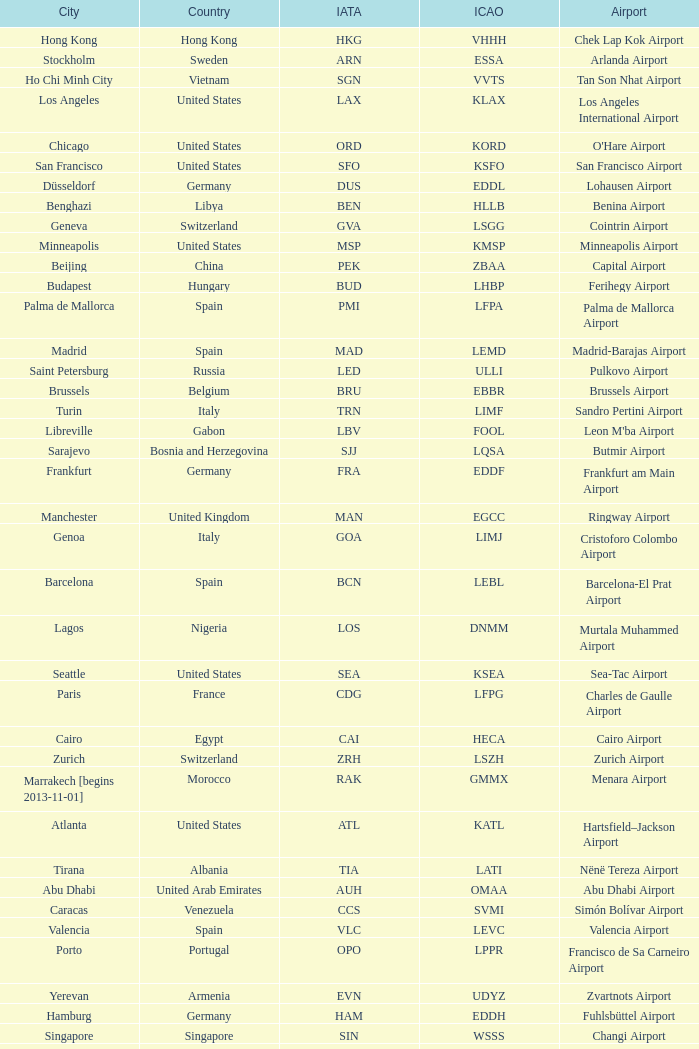Could you parse the entire table? {'header': ['City', 'Country', 'IATA', 'ICAO', 'Airport'], 'rows': [['Hong Kong', 'Hong Kong', 'HKG', 'VHHH', 'Chek Lap Kok Airport'], ['Stockholm', 'Sweden', 'ARN', 'ESSA', 'Arlanda Airport'], ['Ho Chi Minh City', 'Vietnam', 'SGN', 'VVTS', 'Tan Son Nhat Airport'], ['Los Angeles', 'United States', 'LAX', 'KLAX', 'Los Angeles International Airport'], ['Chicago', 'United States', 'ORD', 'KORD', "O'Hare Airport"], ['San Francisco', 'United States', 'SFO', 'KSFO', 'San Francisco Airport'], ['Düsseldorf', 'Germany', 'DUS', 'EDDL', 'Lohausen Airport'], ['Benghazi', 'Libya', 'BEN', 'HLLB', 'Benina Airport'], ['Geneva', 'Switzerland', 'GVA', 'LSGG', 'Cointrin Airport'], ['Minneapolis', 'United States', 'MSP', 'KMSP', 'Minneapolis Airport'], ['Beijing', 'China', 'PEK', 'ZBAA', 'Capital Airport'], ['Budapest', 'Hungary', 'BUD', 'LHBP', 'Ferihegy Airport'], ['Palma de Mallorca', 'Spain', 'PMI', 'LFPA', 'Palma de Mallorca Airport'], ['Madrid', 'Spain', 'MAD', 'LEMD', 'Madrid-Barajas Airport'], ['Saint Petersburg', 'Russia', 'LED', 'ULLI', 'Pulkovo Airport'], ['Brussels', 'Belgium', 'BRU', 'EBBR', 'Brussels Airport'], ['Turin', 'Italy', 'TRN', 'LIMF', 'Sandro Pertini Airport'], ['Libreville', 'Gabon', 'LBV', 'FOOL', "Leon M'ba Airport"], ['Sarajevo', 'Bosnia and Herzegovina', 'SJJ', 'LQSA', 'Butmir Airport'], ['Frankfurt', 'Germany', 'FRA', 'EDDF', 'Frankfurt am Main Airport'], ['Manchester', 'United Kingdom', 'MAN', 'EGCC', 'Ringway Airport'], ['Genoa', 'Italy', 'GOA', 'LIMJ', 'Cristoforo Colombo Airport'], ['Barcelona', 'Spain', 'BCN', 'LEBL', 'Barcelona-El Prat Airport'], ['Lagos', 'Nigeria', 'LOS', 'DNMM', 'Murtala Muhammed Airport'], ['Seattle', 'United States', 'SEA', 'KSEA', 'Sea-Tac Airport'], ['Paris', 'France', 'CDG', 'LFPG', 'Charles de Gaulle Airport'], ['Cairo', 'Egypt', 'CAI', 'HECA', 'Cairo Airport'], ['Zurich', 'Switzerland', 'ZRH', 'LSZH', 'Zurich Airport'], ['Marrakech [begins 2013-11-01]', 'Morocco', 'RAK', 'GMMX', 'Menara Airport'], ['Atlanta', 'United States', 'ATL', 'KATL', 'Hartsfield–Jackson Airport'], ['Tirana', 'Albania', 'TIA', 'LATI', 'Nënë Tereza Airport'], ['Abu Dhabi', 'United Arab Emirates', 'AUH', 'OMAA', 'Abu Dhabi Airport'], ['Caracas', 'Venezuela', 'CCS', 'SVMI', 'Simón Bolívar Airport'], ['Valencia', 'Spain', 'VLC', 'LEVC', 'Valencia Airport'], ['Porto', 'Portugal', 'OPO', 'LPPR', 'Francisco de Sa Carneiro Airport'], ['Yerevan', 'Armenia', 'EVN', 'UDYZ', 'Zvartnots Airport'], ['Hamburg', 'Germany', 'HAM', 'EDDH', 'Fuhlsbüttel Airport'], ['Singapore', 'Singapore', 'SIN', 'WSSS', 'Changi Airport'], ['Munich', 'Germany', 'MUC', 'EDDM', 'Franz Josef Strauss Airport'], ['Thessaloniki', 'Greece', 'SKG', 'LGTS', 'Macedonia Airport'], ['Gothenburg [begins 2013-12-14]', 'Sweden', 'GOT', 'ESGG', 'Gothenburg-Landvetter Airport'], ['Basel Mulhouse Freiburg', 'Switzerland France Germany', 'BSL MLH EAP', 'LFSB', 'Euro Airport'], ['Copenhagen', 'Denmark', 'CPH', 'EKCH', 'Kastrup Airport'], ['London', 'United Kingdom', 'LHR', 'EGLL', 'Heathrow Airport'], ['Tunis', 'Tunisia', 'TUN', 'DTTA', 'Carthage Airport'], ['Accra', 'Ghana', 'ACC', 'DGAA', 'Kotoka Airport'], ['Prague', 'Czech Republic', 'PRG', 'LKPR', 'Ruzyně Airport'], ['New York City', 'United States', 'JFK', 'KJFK', 'John F Kennedy Airport'], ['Malaga', 'Spain', 'AGP', 'LEMG', 'Málaga-Costa del Sol Airport'], ['Stuttgart', 'Germany', 'STR', 'EDDS', 'Echterdingen Airport'], ['Istanbul', 'Turkey', 'IST', 'LTBA', 'Atatürk Airport'], ['Helsinki', 'Finland', 'HEL', 'EFHK', 'Vantaa Airport'], ['Tel Aviv', 'Israel', 'TLV', 'LLBG', 'Ben Gurion Airport'], ['Tehran', 'Iran', 'IKA', 'OIIE', 'Imam Khomeini Airport'], ['Lugano', 'Switzerland', 'LUG', 'LSZA', 'Agno Airport'], ['Bucharest', 'Romania', 'OTP', 'LROP', 'Otopeni Airport'], ['Lyon', 'France', 'LYS', 'LFLL', 'Saint-Exupéry Airport'], ['Karachi', 'Pakistan', 'KHI', 'OPKC', 'Jinnah Airport'], ['Florence', 'Italy', 'FLR', 'LIRQ', 'Peretola Airport'], ['Oslo', 'Norway', 'OSL', 'ENGM', 'Gardermoen Airport'], ['Riga', 'Latvia', 'RIX', 'EVRA', 'Riga Airport'], ['Luxembourg City', 'Luxembourg', 'LUX', 'ELLX', 'Findel Airport'], ['Amsterdam', 'Netherlands', 'AMS', 'EHAM', 'Amsterdam Airport Schiphol'], ['Moscow', 'Russia', 'DME', 'UUDD', 'Domodedovo Airport'], ['Venice', 'Italy', 'VCE', 'LIPZ', 'Marco Polo Airport'], ['Hannover', 'Germany', 'HAJ', 'EDDV', 'Langenhagen Airport'], ['Miami', 'United States', 'MIA', 'KMIA', 'Miami Airport'], ['Jeddah', 'Saudi Arabia', 'JED', 'OEJN', 'King Abdulaziz Airport'], ['London', 'United Kingdom', 'LCY', 'EGLC', 'City Airport'], ['Nuremberg', 'Germany', 'NUE', 'EDDN', 'Nuremberg Airport'], ['Dar es Salaam', 'Tanzania', 'DAR', 'HTDA', 'Julius Nyerere Airport'], ['Vienna', 'Austria', 'VIE', 'LOWW', 'Schwechat Airport'], ['Belgrade', 'Serbia', 'BEG', 'LYBE', 'Nikola Tesla Airport'], ['Mumbai', 'India', 'BOM', 'VABB', 'Chhatrapati Shivaji Airport'], ['Muscat', 'Oman', 'MCT', 'OOMS', 'Seeb Airport'], ['Tripoli', 'Libya', 'TIP', 'HLLT', 'Tripoli Airport'], ['Dublin', 'Ireland', 'DUB', 'EIDW', 'Dublin Airport'], ['Nice', 'France', 'NCE', 'LFMN', "Côte d'Azur Airport"], ['Tokyo', 'Japan', 'NRT', 'RJAA', 'Narita Airport'], ['Dubai', 'United Arab Emirates', 'DXB', 'OMDB', 'Dubai Airport'], ['Sofia', 'Bulgaria', 'SOF', 'LBSF', 'Vrazhdebna Airport'], ['São Paulo', 'Brazil', 'GRU', 'SBGR', 'Guarulhos Airport'], ['Bilbao', 'Spain', 'BIO', 'LEBB', 'Bilbao Airport'], ['Buenos Aires', 'Argentina', 'EZE', 'SAEZ', 'Ministro Pistarini Airport (Ezeiza)'], ['Manila', 'Philippines', 'MNL', 'RPLL', 'Ninoy Aquino Airport'], ['Birmingham', 'United Kingdom', 'BHX', 'EGBB', 'Birmingham Airport'], ['Milan', 'Italy', 'MXP', 'LIMC', 'Malpensa Airport'], ['Douala', 'Cameroon', 'DLA', 'FKKD', 'Douala Airport'], ['London [begins 2013-12-14]', 'United Kingdom', 'LGW', 'EGKK', 'Gatwick Airport'], ['Newark', 'United States', 'EWR', 'KEWR', 'Liberty Airport'], ['Santiago', 'Chile', 'SCL', 'SCEL', 'Comodoro Arturo Benitez Airport'], ['Riyadh', 'Saudi Arabia', 'RUH', 'OERK', 'King Khalid Airport'], ['Beirut', 'Lebanon', 'BEY', 'OLBA', 'Rafic Hariri Airport'], ['Bangkok', 'Thailand', 'BKK', 'VTBS', 'Suvarnabhumi Airport'], ['Rio de Janeiro [resumes 2014-7-14]', 'Brazil', 'GIG', 'SBGL', 'Galeão Airport'], ['Warsaw', 'Poland', 'WAW', 'EPWA', 'Frederic Chopin Airport'], ['Yaounde', 'Cameroon', 'NSI', 'FKYS', 'Yaounde Nsimalen Airport'], ['Malabo', 'Equatorial Guinea', 'SSG', 'FGSL', 'Saint Isabel Airport'], ['Johannesburg', 'South Africa', 'JNB', 'FAJS', 'OR Tambo Airport'], ['Washington DC', 'United States', 'IAD', 'KIAD', 'Dulles Airport'], ['Kiev', 'Ukraine', 'KBP', 'UKBB', 'Boryspil International Airport'], ['Jakarta', 'Indonesia', 'CGK', 'WIII', 'Soekarno–Hatta Airport'], ['Skopje', 'Republic of Macedonia', 'SKP', 'LWSK', 'Alexander the Great Airport'], ['Berlin', 'Germany', 'TXL', 'EDDT', 'Tegel Airport'], ['Casablanca', 'Morocco', 'CMN', 'GMMN', 'Mohammed V Airport'], ['Montreal', 'Canada', 'YUL', 'CYUL', 'Pierre Elliott Trudeau Airport'], ['Taipei', 'Taiwan', 'TPE', 'RCTP', 'Taoyuan Airport'], ['Toronto', 'Canada', 'YYZ', 'CYYZ', 'Pearson Airport'], ['Delhi', 'India', 'DEL', 'VIDP', 'Indira Gandhi Airport'], ['Nairobi', 'Kenya', 'NBO', 'HKJK', 'Jomo Kenyatta Airport'], ['Rome', 'Italy', 'FCO', 'LIRF', 'Leonardo da Vinci Airport'], ['Athens', 'Greece', 'ATH', 'LGAV', 'Eleftherios Venizelos Airport'], ['Boston', 'United States', 'BOS', 'KBOS', 'Logan Airport'], ['Shanghai', 'China', 'PVG', 'ZSPD', 'Pudong Airport'], ['Lisbon', 'Portugal', 'LIS', 'LPPT', 'Portela Airport']]} What is the IATA of galeão airport? GIG. 